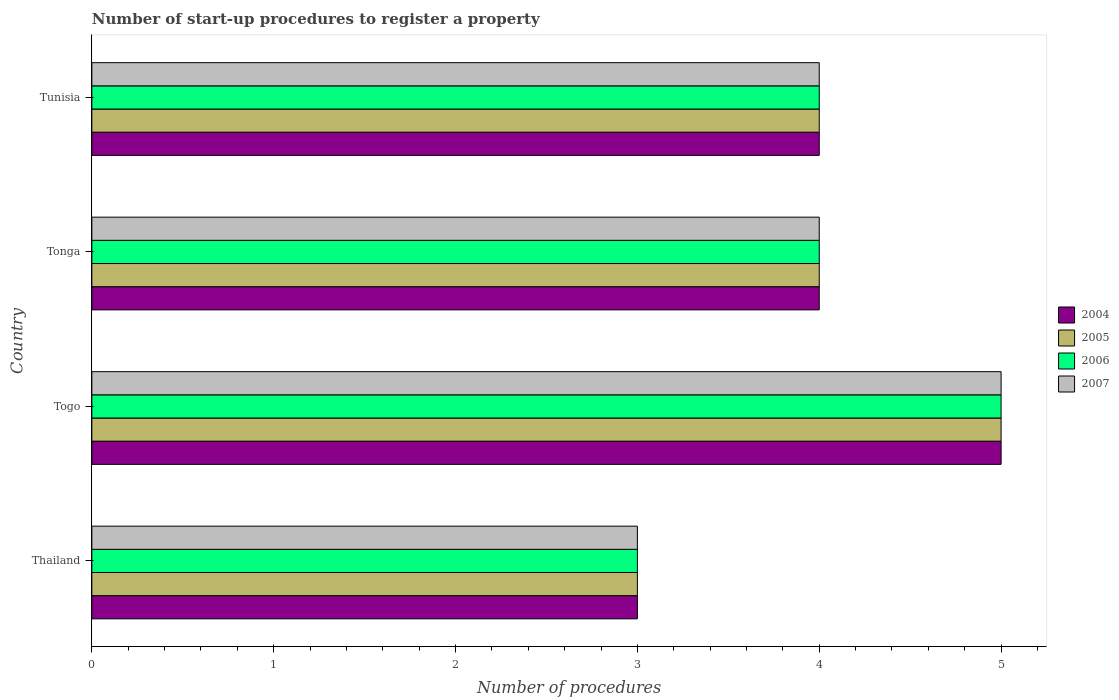How many different coloured bars are there?
Offer a terse response. 4. How many groups of bars are there?
Keep it short and to the point. 4. Are the number of bars per tick equal to the number of legend labels?
Make the answer very short. Yes. Are the number of bars on each tick of the Y-axis equal?
Provide a short and direct response. Yes. How many bars are there on the 3rd tick from the bottom?
Provide a short and direct response. 4. What is the label of the 2nd group of bars from the top?
Your answer should be compact. Tonga. Across all countries, what is the maximum number of procedures required to register a property in 2004?
Your answer should be very brief. 5. In which country was the number of procedures required to register a property in 2004 maximum?
Your response must be concise. Togo. In which country was the number of procedures required to register a property in 2007 minimum?
Provide a succinct answer. Thailand. What is the difference between the number of procedures required to register a property in 2004 in Tunisia and the number of procedures required to register a property in 2006 in Togo?
Give a very brief answer. -1. What is the average number of procedures required to register a property in 2005 per country?
Your response must be concise. 4. In how many countries, is the number of procedures required to register a property in 2005 greater than 2.4 ?
Give a very brief answer. 4. What is the ratio of the number of procedures required to register a property in 2005 in Tonga to that in Tunisia?
Provide a succinct answer. 1. Is it the case that in every country, the sum of the number of procedures required to register a property in 2005 and number of procedures required to register a property in 2004 is greater than the sum of number of procedures required to register a property in 2006 and number of procedures required to register a property in 2007?
Your answer should be very brief. No. What does the 3rd bar from the top in Tunisia represents?
Make the answer very short. 2005. How many bars are there?
Offer a very short reply. 16. How many countries are there in the graph?
Your answer should be compact. 4. What is the difference between two consecutive major ticks on the X-axis?
Your answer should be very brief. 1. Are the values on the major ticks of X-axis written in scientific E-notation?
Your answer should be compact. No. Does the graph contain any zero values?
Provide a short and direct response. No. Does the graph contain grids?
Provide a short and direct response. No. Where does the legend appear in the graph?
Offer a very short reply. Center right. How many legend labels are there?
Your answer should be very brief. 4. How are the legend labels stacked?
Your answer should be compact. Vertical. What is the title of the graph?
Keep it short and to the point. Number of start-up procedures to register a property. Does "1974" appear as one of the legend labels in the graph?
Offer a very short reply. No. What is the label or title of the X-axis?
Your answer should be very brief. Number of procedures. What is the Number of procedures of 2005 in Thailand?
Ensure brevity in your answer.  3. What is the Number of procedures in 2006 in Thailand?
Offer a terse response. 3. What is the Number of procedures of 2005 in Togo?
Provide a short and direct response. 5. What is the Number of procedures of 2006 in Togo?
Your response must be concise. 5. What is the Number of procedures in 2004 in Tonga?
Make the answer very short. 4. What is the Number of procedures in 2006 in Tonga?
Give a very brief answer. 4. What is the Number of procedures of 2005 in Tunisia?
Your answer should be very brief. 4. Across all countries, what is the maximum Number of procedures in 2004?
Offer a terse response. 5. Across all countries, what is the maximum Number of procedures in 2005?
Make the answer very short. 5. Across all countries, what is the minimum Number of procedures of 2006?
Offer a very short reply. 3. Across all countries, what is the minimum Number of procedures in 2007?
Ensure brevity in your answer.  3. What is the total Number of procedures in 2004 in the graph?
Give a very brief answer. 16. What is the total Number of procedures in 2006 in the graph?
Ensure brevity in your answer.  16. What is the difference between the Number of procedures in 2004 in Thailand and that in Togo?
Keep it short and to the point. -2. What is the difference between the Number of procedures of 2005 in Thailand and that in Togo?
Your answer should be compact. -2. What is the difference between the Number of procedures of 2007 in Thailand and that in Tonga?
Your response must be concise. -1. What is the difference between the Number of procedures in 2004 in Thailand and that in Tunisia?
Keep it short and to the point. -1. What is the difference between the Number of procedures in 2007 in Thailand and that in Tunisia?
Keep it short and to the point. -1. What is the difference between the Number of procedures of 2004 in Togo and that in Tonga?
Give a very brief answer. 1. What is the difference between the Number of procedures of 2007 in Togo and that in Tonga?
Keep it short and to the point. 1. What is the difference between the Number of procedures of 2005 in Togo and that in Tunisia?
Ensure brevity in your answer.  1. What is the difference between the Number of procedures of 2007 in Togo and that in Tunisia?
Provide a succinct answer. 1. What is the difference between the Number of procedures in 2005 in Tonga and that in Tunisia?
Offer a terse response. 0. What is the difference between the Number of procedures in 2006 in Tonga and that in Tunisia?
Your answer should be compact. 0. What is the difference between the Number of procedures of 2004 in Thailand and the Number of procedures of 2006 in Togo?
Give a very brief answer. -2. What is the difference between the Number of procedures in 2005 in Thailand and the Number of procedures in 2006 in Togo?
Your response must be concise. -2. What is the difference between the Number of procedures in 2005 in Thailand and the Number of procedures in 2007 in Togo?
Keep it short and to the point. -2. What is the difference between the Number of procedures in 2005 in Thailand and the Number of procedures in 2007 in Tonga?
Provide a succinct answer. -1. What is the difference between the Number of procedures of 2006 in Thailand and the Number of procedures of 2007 in Tonga?
Ensure brevity in your answer.  -1. What is the difference between the Number of procedures in 2005 in Thailand and the Number of procedures in 2007 in Tunisia?
Your answer should be compact. -1. What is the difference between the Number of procedures of 2006 in Thailand and the Number of procedures of 2007 in Tunisia?
Provide a short and direct response. -1. What is the difference between the Number of procedures of 2004 in Togo and the Number of procedures of 2007 in Tonga?
Keep it short and to the point. 1. What is the difference between the Number of procedures in 2005 in Togo and the Number of procedures in 2006 in Tonga?
Keep it short and to the point. 1. What is the difference between the Number of procedures in 2005 in Togo and the Number of procedures in 2007 in Tonga?
Provide a short and direct response. 1. What is the difference between the Number of procedures in 2004 in Togo and the Number of procedures in 2005 in Tunisia?
Ensure brevity in your answer.  1. What is the difference between the Number of procedures of 2004 in Togo and the Number of procedures of 2006 in Tunisia?
Your response must be concise. 1. What is the difference between the Number of procedures in 2004 in Tonga and the Number of procedures in 2005 in Tunisia?
Your response must be concise. 0. What is the difference between the Number of procedures of 2004 in Tonga and the Number of procedures of 2006 in Tunisia?
Provide a succinct answer. 0. What is the difference between the Number of procedures of 2004 in Tonga and the Number of procedures of 2007 in Tunisia?
Offer a terse response. 0. What is the difference between the Number of procedures in 2005 in Tonga and the Number of procedures in 2007 in Tunisia?
Your response must be concise. 0. What is the difference between the Number of procedures of 2006 in Tonga and the Number of procedures of 2007 in Tunisia?
Keep it short and to the point. 0. What is the average Number of procedures in 2006 per country?
Your answer should be very brief. 4. What is the average Number of procedures of 2007 per country?
Your answer should be very brief. 4. What is the difference between the Number of procedures of 2004 and Number of procedures of 2005 in Thailand?
Your answer should be very brief. 0. What is the difference between the Number of procedures of 2004 and Number of procedures of 2006 in Thailand?
Provide a short and direct response. 0. What is the difference between the Number of procedures of 2005 and Number of procedures of 2006 in Thailand?
Provide a short and direct response. 0. What is the difference between the Number of procedures of 2005 and Number of procedures of 2007 in Thailand?
Keep it short and to the point. 0. What is the difference between the Number of procedures in 2004 and Number of procedures in 2005 in Togo?
Offer a very short reply. 0. What is the difference between the Number of procedures of 2005 and Number of procedures of 2006 in Togo?
Make the answer very short. 0. What is the difference between the Number of procedures in 2005 and Number of procedures in 2006 in Tonga?
Make the answer very short. 0. What is the difference between the Number of procedures in 2005 and Number of procedures in 2007 in Tonga?
Offer a very short reply. 0. What is the difference between the Number of procedures in 2006 and Number of procedures in 2007 in Tonga?
Ensure brevity in your answer.  0. What is the difference between the Number of procedures in 2004 and Number of procedures in 2007 in Tunisia?
Give a very brief answer. 0. What is the ratio of the Number of procedures of 2005 in Thailand to that in Togo?
Provide a succinct answer. 0.6. What is the ratio of the Number of procedures in 2006 in Thailand to that in Tonga?
Offer a very short reply. 0.75. What is the ratio of the Number of procedures in 2007 in Thailand to that in Tonga?
Offer a very short reply. 0.75. What is the ratio of the Number of procedures in 2004 in Thailand to that in Tunisia?
Your answer should be very brief. 0.75. What is the ratio of the Number of procedures in 2005 in Thailand to that in Tunisia?
Your response must be concise. 0.75. What is the ratio of the Number of procedures in 2006 in Thailand to that in Tunisia?
Provide a short and direct response. 0.75. What is the ratio of the Number of procedures in 2007 in Thailand to that in Tunisia?
Your answer should be compact. 0.75. What is the ratio of the Number of procedures in 2005 in Togo to that in Tonga?
Offer a terse response. 1.25. What is the ratio of the Number of procedures of 2006 in Togo to that in Tonga?
Offer a very short reply. 1.25. What is the ratio of the Number of procedures in 2007 in Togo to that in Tonga?
Your answer should be compact. 1.25. What is the ratio of the Number of procedures in 2004 in Togo to that in Tunisia?
Your answer should be compact. 1.25. What is the ratio of the Number of procedures of 2005 in Togo to that in Tunisia?
Offer a very short reply. 1.25. What is the ratio of the Number of procedures in 2007 in Togo to that in Tunisia?
Give a very brief answer. 1.25. What is the ratio of the Number of procedures of 2005 in Tonga to that in Tunisia?
Your response must be concise. 1. What is the ratio of the Number of procedures of 2006 in Tonga to that in Tunisia?
Keep it short and to the point. 1. What is the ratio of the Number of procedures of 2007 in Tonga to that in Tunisia?
Keep it short and to the point. 1. What is the difference between the highest and the second highest Number of procedures in 2004?
Keep it short and to the point. 1. What is the difference between the highest and the second highest Number of procedures of 2006?
Make the answer very short. 1. What is the difference between the highest and the second highest Number of procedures in 2007?
Your answer should be compact. 1. 